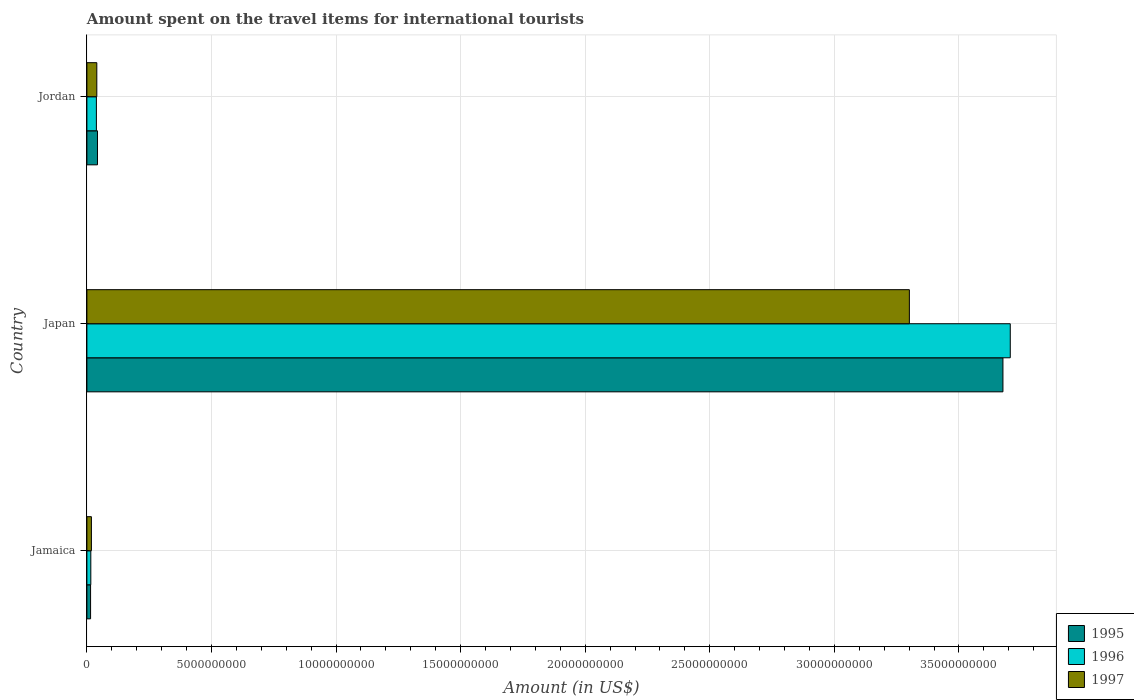How many bars are there on the 1st tick from the bottom?
Offer a terse response. 3. What is the label of the 3rd group of bars from the top?
Provide a short and direct response. Jamaica. What is the amount spent on the travel items for international tourists in 1996 in Japan?
Give a very brief answer. 3.71e+1. Across all countries, what is the maximum amount spent on the travel items for international tourists in 1997?
Your answer should be very brief. 3.30e+1. Across all countries, what is the minimum amount spent on the travel items for international tourists in 1995?
Ensure brevity in your answer.  1.48e+08. In which country was the amount spent on the travel items for international tourists in 1996 maximum?
Make the answer very short. Japan. In which country was the amount spent on the travel items for international tourists in 1995 minimum?
Offer a very short reply. Jamaica. What is the total amount spent on the travel items for international tourists in 1997 in the graph?
Keep it short and to the point. 3.36e+1. What is the difference between the amount spent on the travel items for international tourists in 1996 in Japan and that in Jordan?
Provide a succinct answer. 3.67e+1. What is the difference between the amount spent on the travel items for international tourists in 1996 in Jordan and the amount spent on the travel items for international tourists in 1995 in Japan?
Offer a terse response. -3.64e+1. What is the average amount spent on the travel items for international tourists in 1997 per country?
Provide a short and direct response. 1.12e+1. What is the difference between the amount spent on the travel items for international tourists in 1997 and amount spent on the travel items for international tourists in 1995 in Jordan?
Give a very brief answer. -2.70e+07. What is the ratio of the amount spent on the travel items for international tourists in 1996 in Jamaica to that in Jordan?
Provide a succinct answer. 0.41. Is the amount spent on the travel items for international tourists in 1997 in Japan less than that in Jordan?
Your response must be concise. No. What is the difference between the highest and the second highest amount spent on the travel items for international tourists in 1997?
Ensure brevity in your answer.  3.26e+1. What is the difference between the highest and the lowest amount spent on the travel items for international tourists in 1997?
Give a very brief answer. 3.28e+1. In how many countries, is the amount spent on the travel items for international tourists in 1997 greater than the average amount spent on the travel items for international tourists in 1997 taken over all countries?
Offer a terse response. 1. Is the sum of the amount spent on the travel items for international tourists in 1997 in Japan and Jordan greater than the maximum amount spent on the travel items for international tourists in 1995 across all countries?
Your response must be concise. No. What does the 2nd bar from the top in Jordan represents?
Ensure brevity in your answer.  1996. What does the 1st bar from the bottom in Jordan represents?
Your answer should be compact. 1995. How many bars are there?
Make the answer very short. 9. Are all the bars in the graph horizontal?
Your response must be concise. Yes. Are the values on the major ticks of X-axis written in scientific E-notation?
Your answer should be very brief. No. Where does the legend appear in the graph?
Offer a very short reply. Bottom right. How many legend labels are there?
Make the answer very short. 3. What is the title of the graph?
Your answer should be very brief. Amount spent on the travel items for international tourists. Does "1964" appear as one of the legend labels in the graph?
Ensure brevity in your answer.  No. What is the label or title of the Y-axis?
Ensure brevity in your answer.  Country. What is the Amount (in US$) of 1995 in Jamaica?
Give a very brief answer. 1.48e+08. What is the Amount (in US$) of 1996 in Jamaica?
Your answer should be very brief. 1.57e+08. What is the Amount (in US$) in 1997 in Jamaica?
Ensure brevity in your answer.  1.81e+08. What is the Amount (in US$) in 1995 in Japan?
Offer a very short reply. 3.68e+1. What is the Amount (in US$) of 1996 in Japan?
Offer a very short reply. 3.71e+1. What is the Amount (in US$) in 1997 in Japan?
Give a very brief answer. 3.30e+1. What is the Amount (in US$) of 1995 in Jordan?
Offer a very short reply. 4.25e+08. What is the Amount (in US$) of 1996 in Jordan?
Give a very brief answer. 3.81e+08. What is the Amount (in US$) in 1997 in Jordan?
Your response must be concise. 3.98e+08. Across all countries, what is the maximum Amount (in US$) in 1995?
Your answer should be very brief. 3.68e+1. Across all countries, what is the maximum Amount (in US$) in 1996?
Your answer should be very brief. 3.71e+1. Across all countries, what is the maximum Amount (in US$) in 1997?
Keep it short and to the point. 3.30e+1. Across all countries, what is the minimum Amount (in US$) in 1995?
Provide a succinct answer. 1.48e+08. Across all countries, what is the minimum Amount (in US$) in 1996?
Make the answer very short. 1.57e+08. Across all countries, what is the minimum Amount (in US$) of 1997?
Your response must be concise. 1.81e+08. What is the total Amount (in US$) in 1995 in the graph?
Give a very brief answer. 3.73e+1. What is the total Amount (in US$) of 1996 in the graph?
Provide a short and direct response. 3.76e+1. What is the total Amount (in US$) of 1997 in the graph?
Offer a terse response. 3.36e+1. What is the difference between the Amount (in US$) in 1995 in Jamaica and that in Japan?
Your answer should be compact. -3.66e+1. What is the difference between the Amount (in US$) in 1996 in Jamaica and that in Japan?
Your answer should be very brief. -3.69e+1. What is the difference between the Amount (in US$) of 1997 in Jamaica and that in Japan?
Your response must be concise. -3.28e+1. What is the difference between the Amount (in US$) in 1995 in Jamaica and that in Jordan?
Ensure brevity in your answer.  -2.77e+08. What is the difference between the Amount (in US$) in 1996 in Jamaica and that in Jordan?
Your answer should be compact. -2.24e+08. What is the difference between the Amount (in US$) in 1997 in Jamaica and that in Jordan?
Your response must be concise. -2.17e+08. What is the difference between the Amount (in US$) of 1995 in Japan and that in Jordan?
Your answer should be very brief. 3.63e+1. What is the difference between the Amount (in US$) in 1996 in Japan and that in Jordan?
Ensure brevity in your answer.  3.67e+1. What is the difference between the Amount (in US$) of 1997 in Japan and that in Jordan?
Offer a terse response. 3.26e+1. What is the difference between the Amount (in US$) of 1995 in Jamaica and the Amount (in US$) of 1996 in Japan?
Your answer should be very brief. -3.69e+1. What is the difference between the Amount (in US$) of 1995 in Jamaica and the Amount (in US$) of 1997 in Japan?
Your answer should be compact. -3.29e+1. What is the difference between the Amount (in US$) of 1996 in Jamaica and the Amount (in US$) of 1997 in Japan?
Give a very brief answer. -3.29e+1. What is the difference between the Amount (in US$) in 1995 in Jamaica and the Amount (in US$) in 1996 in Jordan?
Ensure brevity in your answer.  -2.33e+08. What is the difference between the Amount (in US$) in 1995 in Jamaica and the Amount (in US$) in 1997 in Jordan?
Give a very brief answer. -2.50e+08. What is the difference between the Amount (in US$) in 1996 in Jamaica and the Amount (in US$) in 1997 in Jordan?
Your answer should be compact. -2.41e+08. What is the difference between the Amount (in US$) of 1995 in Japan and the Amount (in US$) of 1996 in Jordan?
Give a very brief answer. 3.64e+1. What is the difference between the Amount (in US$) of 1995 in Japan and the Amount (in US$) of 1997 in Jordan?
Keep it short and to the point. 3.64e+1. What is the difference between the Amount (in US$) in 1996 in Japan and the Amount (in US$) in 1997 in Jordan?
Your response must be concise. 3.67e+1. What is the average Amount (in US$) of 1995 per country?
Your response must be concise. 1.24e+1. What is the average Amount (in US$) in 1996 per country?
Offer a very short reply. 1.25e+1. What is the average Amount (in US$) in 1997 per country?
Make the answer very short. 1.12e+1. What is the difference between the Amount (in US$) of 1995 and Amount (in US$) of 1996 in Jamaica?
Your response must be concise. -9.00e+06. What is the difference between the Amount (in US$) of 1995 and Amount (in US$) of 1997 in Jamaica?
Provide a succinct answer. -3.30e+07. What is the difference between the Amount (in US$) of 1996 and Amount (in US$) of 1997 in Jamaica?
Offer a very short reply. -2.40e+07. What is the difference between the Amount (in US$) in 1995 and Amount (in US$) in 1996 in Japan?
Your answer should be very brief. -2.94e+08. What is the difference between the Amount (in US$) in 1995 and Amount (in US$) in 1997 in Japan?
Your answer should be compact. 3.76e+09. What is the difference between the Amount (in US$) in 1996 and Amount (in US$) in 1997 in Japan?
Your response must be concise. 4.05e+09. What is the difference between the Amount (in US$) in 1995 and Amount (in US$) in 1996 in Jordan?
Ensure brevity in your answer.  4.40e+07. What is the difference between the Amount (in US$) of 1995 and Amount (in US$) of 1997 in Jordan?
Provide a short and direct response. 2.70e+07. What is the difference between the Amount (in US$) in 1996 and Amount (in US$) in 1997 in Jordan?
Offer a terse response. -1.70e+07. What is the ratio of the Amount (in US$) in 1995 in Jamaica to that in Japan?
Your response must be concise. 0. What is the ratio of the Amount (in US$) in 1996 in Jamaica to that in Japan?
Offer a terse response. 0. What is the ratio of the Amount (in US$) in 1997 in Jamaica to that in Japan?
Offer a very short reply. 0.01. What is the ratio of the Amount (in US$) of 1995 in Jamaica to that in Jordan?
Your answer should be compact. 0.35. What is the ratio of the Amount (in US$) of 1996 in Jamaica to that in Jordan?
Provide a short and direct response. 0.41. What is the ratio of the Amount (in US$) in 1997 in Jamaica to that in Jordan?
Give a very brief answer. 0.45. What is the ratio of the Amount (in US$) of 1995 in Japan to that in Jordan?
Make the answer very short. 86.5. What is the ratio of the Amount (in US$) of 1996 in Japan to that in Jordan?
Make the answer very short. 97.27. What is the ratio of the Amount (in US$) of 1997 in Japan to that in Jordan?
Offer a terse response. 82.94. What is the difference between the highest and the second highest Amount (in US$) of 1995?
Give a very brief answer. 3.63e+1. What is the difference between the highest and the second highest Amount (in US$) of 1996?
Ensure brevity in your answer.  3.67e+1. What is the difference between the highest and the second highest Amount (in US$) in 1997?
Your answer should be compact. 3.26e+1. What is the difference between the highest and the lowest Amount (in US$) in 1995?
Your answer should be compact. 3.66e+1. What is the difference between the highest and the lowest Amount (in US$) of 1996?
Provide a short and direct response. 3.69e+1. What is the difference between the highest and the lowest Amount (in US$) of 1997?
Give a very brief answer. 3.28e+1. 